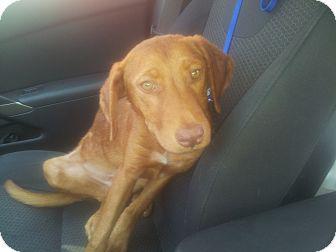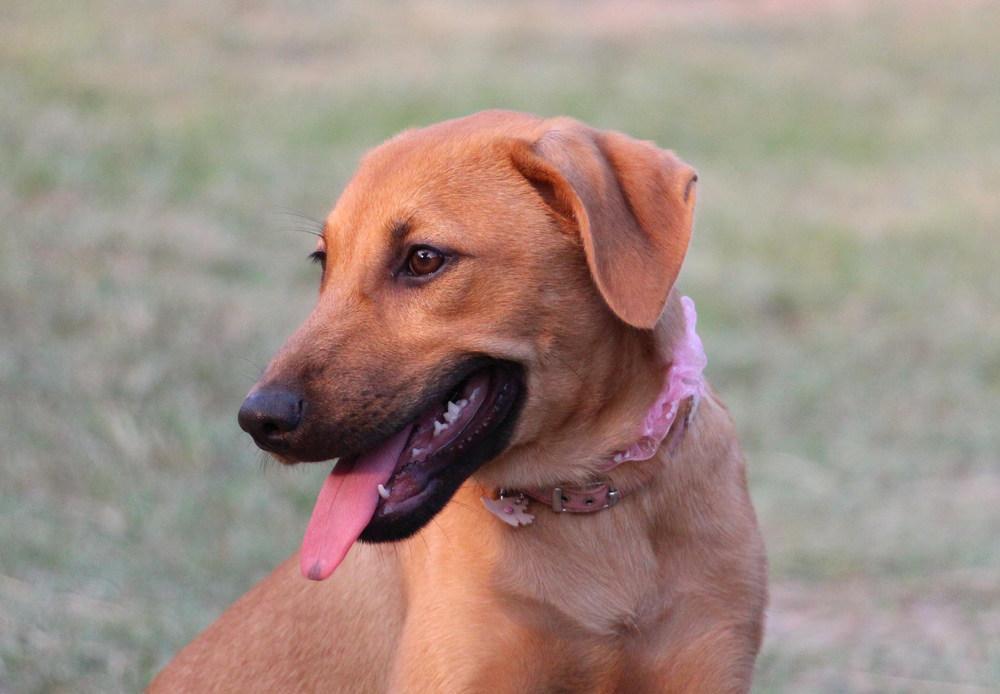The first image is the image on the left, the second image is the image on the right. Analyze the images presented: Is the assertion "The dogs in both of the images are outside." valid? Answer yes or no. No. The first image is the image on the left, the second image is the image on the right. Assess this claim about the two images: "One image features a dog in a collar with his head angled to the left and his tongue hanging down.". Correct or not? Answer yes or no. Yes. 